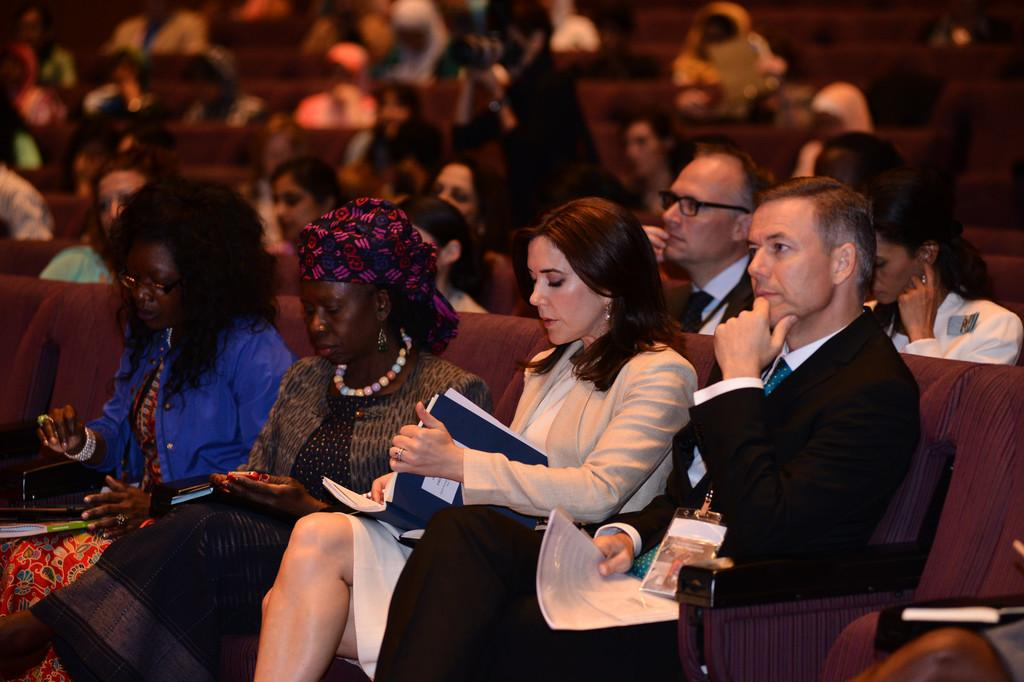How many people are present in the image? There are people in the image, but the exact number is not specified. What are some of the people doing in the image? Some people are sitting on seats, while others are holding a camera, books, or papers. Can you describe the background of the image? The background is blurred. What type of insurance policy is being discussed by the people in the image? There is no indication in the image that people are discussing insurance policies. --- Facts: 1. There is a car in the image. 2. The car is parked on the street. 3. There are trees in the background. 4. The sky is visible in the image. 5. The car has a red color. Absurd Topics: parrot, dance, ocean Conversation: What type of vehicle is in the image? There is a car in the image. Where is the car located in the image? The car is parked on the street. What can be seen in the background of the image? There are trees in the background, and the sky is visible. What is the color of the car in the image? The car has a red color. Reasoning: Let's think step by step in order to produce the conversation. We start by identifying the main subject in the image, which is the car. Then, we expand the conversation to include the location of the car, the background, and the color of the car. Each question is designed to elicit a specific detail about the image that is known from the provided facts. Absurd Question/Answer: Can you tell me how many parrots are sitting on the car in the image? There are no parrots present in the image; it features a red car parked on the street with trees and the sky visible in the background. 